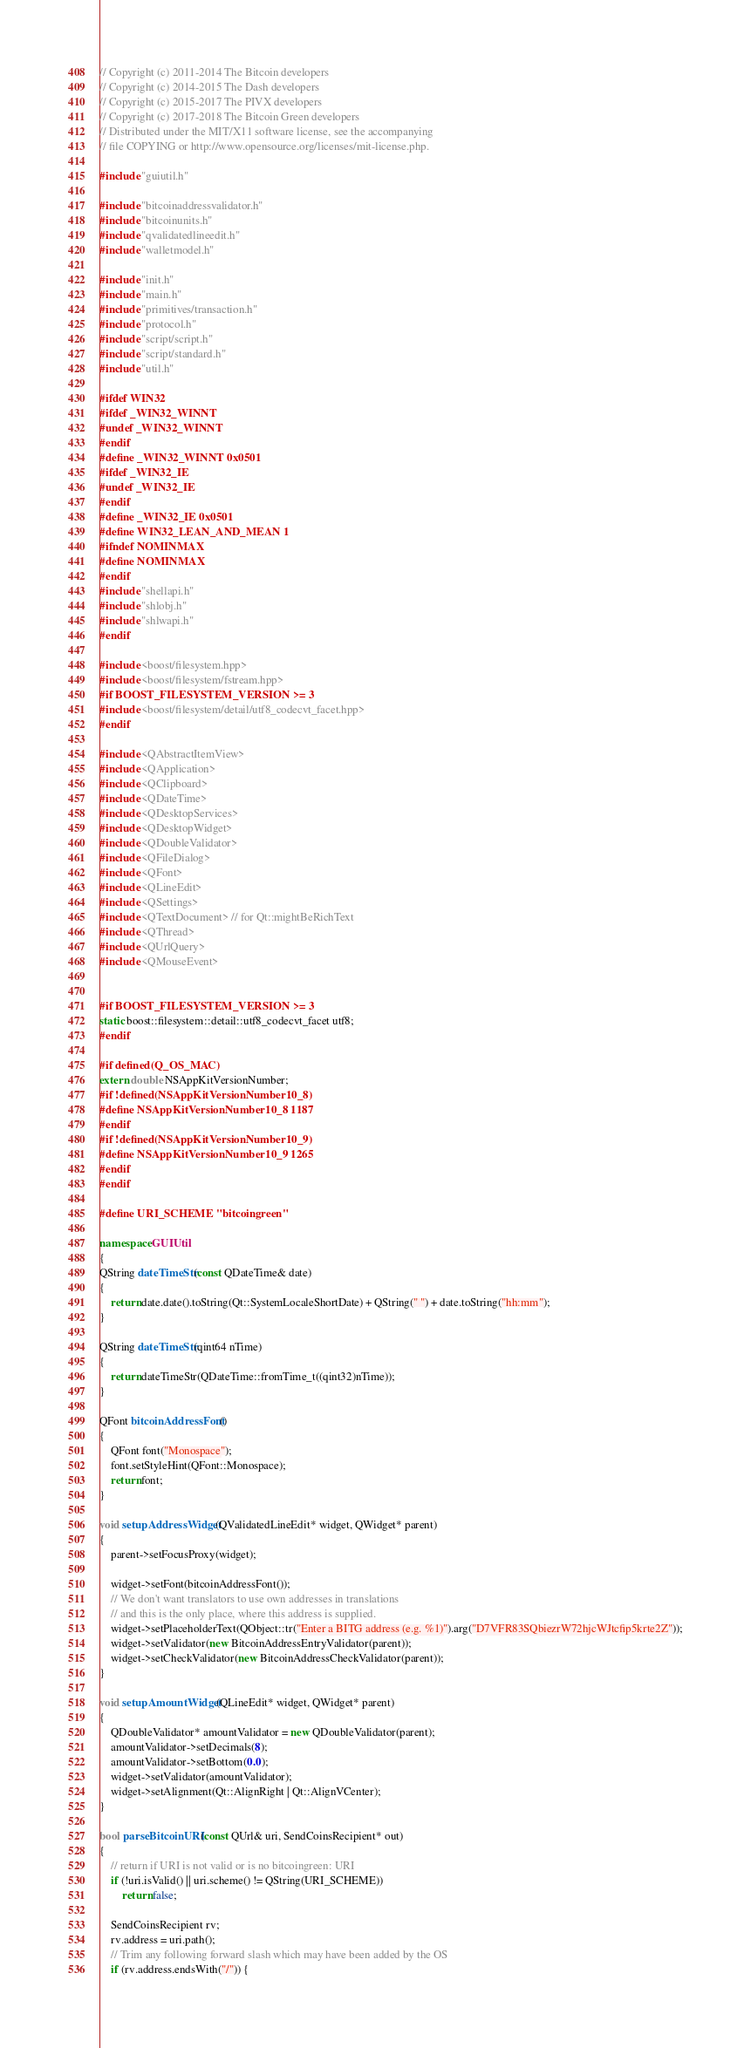<code> <loc_0><loc_0><loc_500><loc_500><_C++_>// Copyright (c) 2011-2014 The Bitcoin developers
// Copyright (c) 2014-2015 The Dash developers
// Copyright (c) 2015-2017 The PIVX developers
// Copyright (c) 2017-2018 The Bitcoin Green developers
// Distributed under the MIT/X11 software license, see the accompanying
// file COPYING or http://www.opensource.org/licenses/mit-license.php.

#include "guiutil.h"

#include "bitcoinaddressvalidator.h"
#include "bitcoinunits.h"
#include "qvalidatedlineedit.h"
#include "walletmodel.h"

#include "init.h"
#include "main.h"
#include "primitives/transaction.h"
#include "protocol.h"
#include "script/script.h"
#include "script/standard.h"
#include "util.h"

#ifdef WIN32
#ifdef _WIN32_WINNT
#undef _WIN32_WINNT
#endif
#define _WIN32_WINNT 0x0501
#ifdef _WIN32_IE
#undef _WIN32_IE
#endif
#define _WIN32_IE 0x0501
#define WIN32_LEAN_AND_MEAN 1
#ifndef NOMINMAX
#define NOMINMAX
#endif
#include "shellapi.h"
#include "shlobj.h"
#include "shlwapi.h"
#endif

#include <boost/filesystem.hpp>
#include <boost/filesystem/fstream.hpp>
#if BOOST_FILESYSTEM_VERSION >= 3
#include <boost/filesystem/detail/utf8_codecvt_facet.hpp>
#endif

#include <QAbstractItemView>
#include <QApplication>
#include <QClipboard>
#include <QDateTime>
#include <QDesktopServices>
#include <QDesktopWidget>
#include <QDoubleValidator>
#include <QFileDialog>
#include <QFont>
#include <QLineEdit>
#include <QSettings>
#include <QTextDocument> // for Qt::mightBeRichText
#include <QThread>
#include <QUrlQuery>
#include <QMouseEvent>


#if BOOST_FILESYSTEM_VERSION >= 3
static boost::filesystem::detail::utf8_codecvt_facet utf8;
#endif

#if defined(Q_OS_MAC)
extern double NSAppKitVersionNumber;
#if !defined(NSAppKitVersionNumber10_8)
#define NSAppKitVersionNumber10_8 1187
#endif
#if !defined(NSAppKitVersionNumber10_9)
#define NSAppKitVersionNumber10_9 1265
#endif
#endif

#define URI_SCHEME "bitcoingreen"

namespace GUIUtil
{
QString dateTimeStr(const QDateTime& date)
{
    return date.date().toString(Qt::SystemLocaleShortDate) + QString(" ") + date.toString("hh:mm");
}

QString dateTimeStr(qint64 nTime)
{
    return dateTimeStr(QDateTime::fromTime_t((qint32)nTime));
}

QFont bitcoinAddressFont()
{
    QFont font("Monospace");
    font.setStyleHint(QFont::Monospace);
    return font;
}

void setupAddressWidget(QValidatedLineEdit* widget, QWidget* parent)
{
    parent->setFocusProxy(widget);

    widget->setFont(bitcoinAddressFont());
    // We don't want translators to use own addresses in translations
    // and this is the only place, where this address is supplied.
    widget->setPlaceholderText(QObject::tr("Enter a BITG address (e.g. %1)").arg("D7VFR83SQbiezrW72hjcWJtcfip5krte2Z"));
    widget->setValidator(new BitcoinAddressEntryValidator(parent));
    widget->setCheckValidator(new BitcoinAddressCheckValidator(parent));
}

void setupAmountWidget(QLineEdit* widget, QWidget* parent)
{
    QDoubleValidator* amountValidator = new QDoubleValidator(parent);
    amountValidator->setDecimals(8);
    amountValidator->setBottom(0.0);
    widget->setValidator(amountValidator);
    widget->setAlignment(Qt::AlignRight | Qt::AlignVCenter);
}

bool parseBitcoinURI(const QUrl& uri, SendCoinsRecipient* out)
{
    // return if URI is not valid or is no bitcoingreen: URI
    if (!uri.isValid() || uri.scheme() != QString(URI_SCHEME))
        return false;

    SendCoinsRecipient rv;
    rv.address = uri.path();
    // Trim any following forward slash which may have been added by the OS
    if (rv.address.endsWith("/")) {</code> 